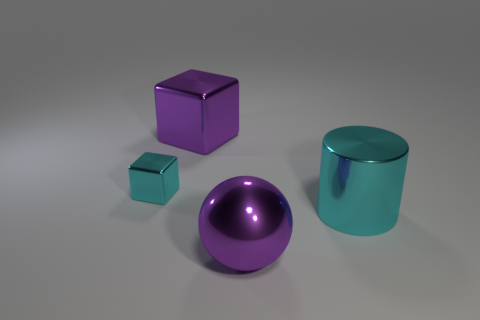Add 3 small red cylinders. How many objects exist? 7 Subtract all cylinders. How many objects are left? 3 Add 3 big cyan metal cylinders. How many big cyan metal cylinders exist? 4 Subtract 1 cyan cubes. How many objects are left? 3 Subtract all large gray balls. Subtract all cyan cylinders. How many objects are left? 3 Add 1 purple objects. How many purple objects are left? 3 